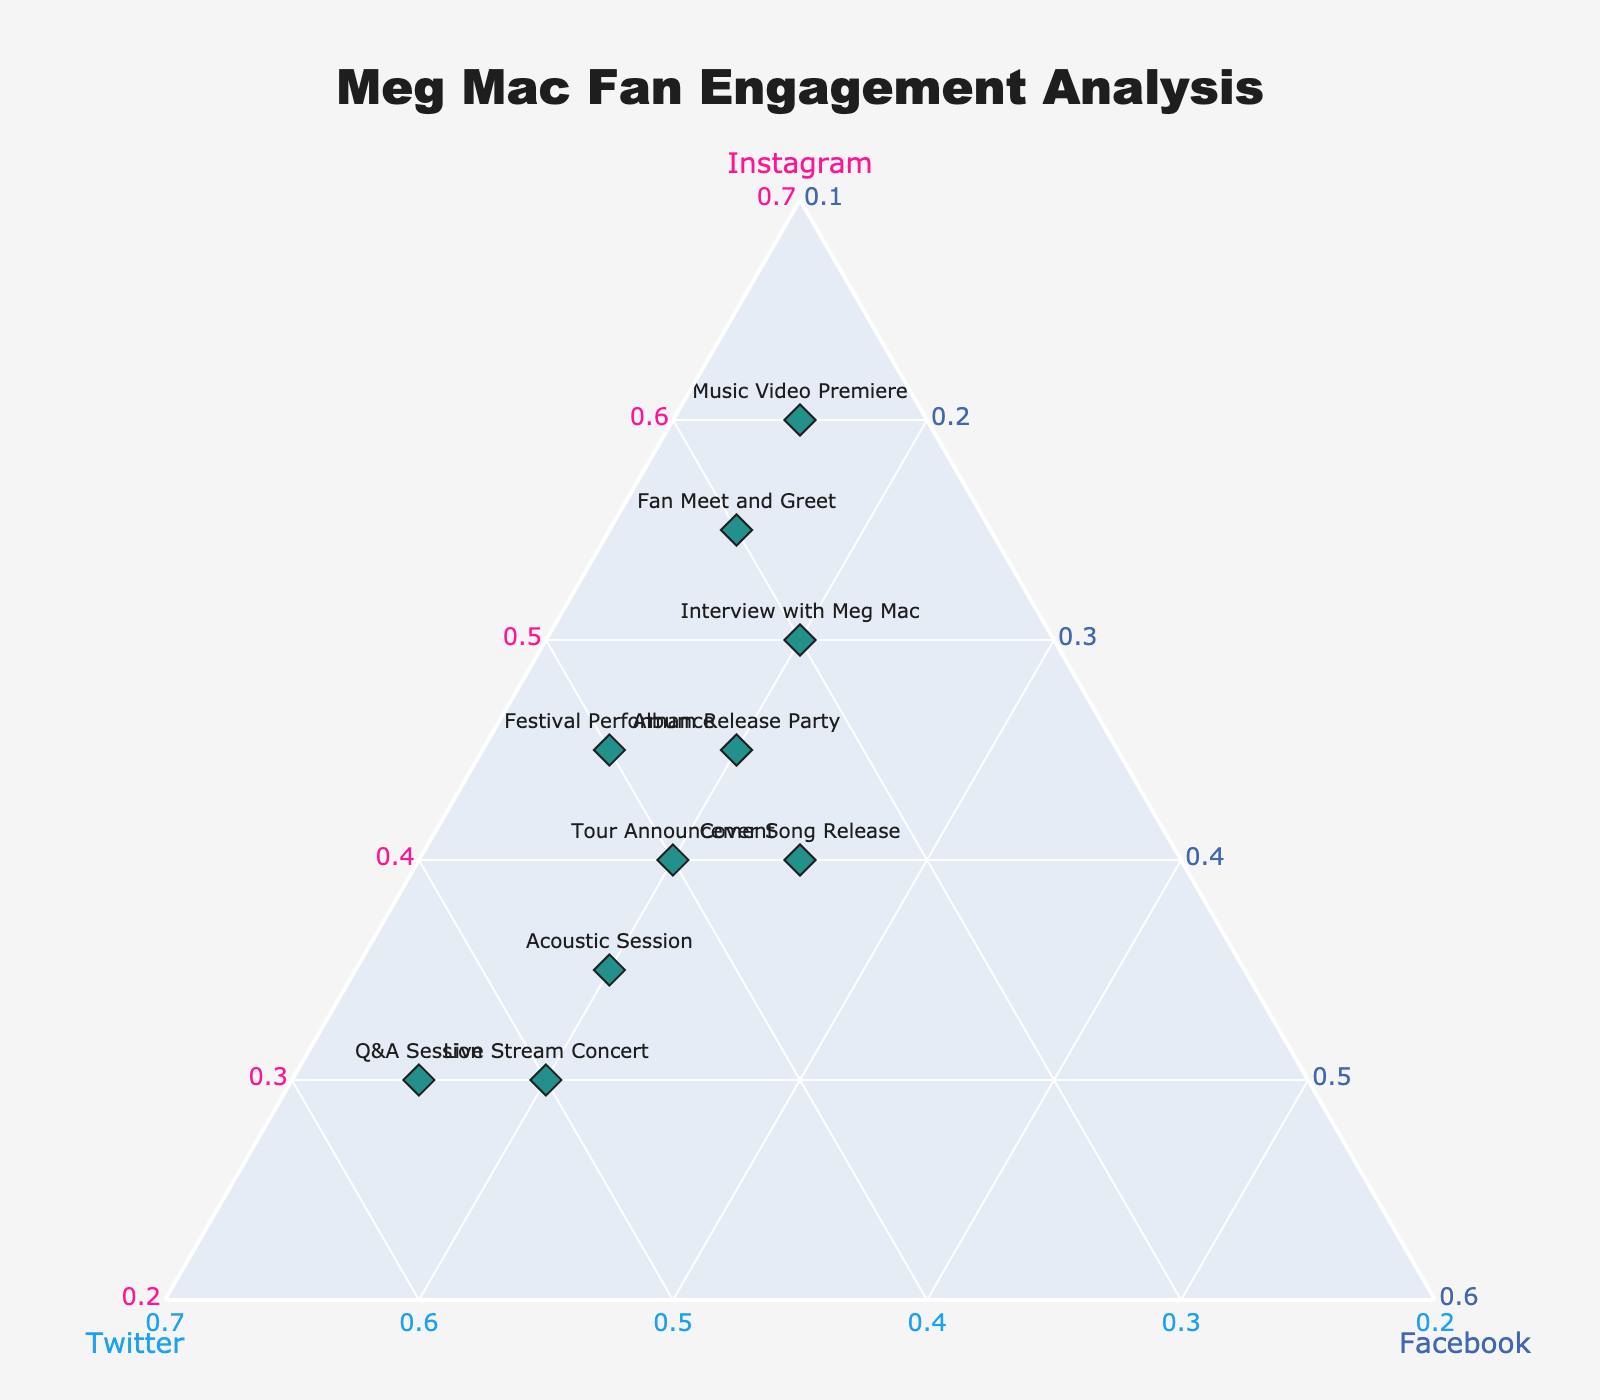What is the title of the ternary plot? The title of the ternary plot is prominently displayed at the top of the plot.
Answer: Meg Mac Fan Engagement Analysis What event had the highest engagement on Instagram? The point that is closest to the Instagram corner of the plot represents the event with the highest Instagram engagement.
Answer: Music Video Premiere Which event has equal engagement on Twitter and Facebook? The event point lying along the bisector line between Twitter and Facebook axes indicates equal engagement on these platforms.
Answer: Cover Song Release How many events have Twitter engagement greater than 40%? Count the data points that lie closer to the Twitter axis than halfway to the other two axes, indicating more than 40% engagement.
Answer: 3 What colors are used to represent the axes in the plot? The axis titles' colors are used to give visual clarity, with distinct colors assigned to each axis.
Answer: Instagram in pink, Twitter in blue, Facebook in dark blue Which event shows the lowest total engagement across all platforms? The point with the smallest marker size represents the lowest total engagement, as marker size correlates with engagement.
Answer: Q&A Session What event balances fan engagement almost equally across all three platforms? The event closest to the center of the ternary plot indicates relatively balanced engagement across Instagram, Twitter, and Facebook.
Answer: Tour Announcement How does the engagement for the 'Album Release Party' compare between Instagram and Facebook? Observe the positions on the plot, particularly along the Instagram and Facebook axes, to compare engagements.
Answer: Higher on Instagram than Facebook Which event had the highest normalized engagement score on Facebook? The point closest to the Facebook corner (lower left of the triangle) represents the event with the highest Facebook engagement.
Answer: Tour Announcement What is the relationship between 'Live Stream Concert' and 'Acoustic Session' in terms of engagement? Look at the positioning of these two events in the ternary plot relative to each axis, especially the Twitter and Instagram axes, to infer engagement.
Answer: 'Live Stream Concert' has higher Twitter engagement, 'Acoustic Session' has higher Instagram engagement 